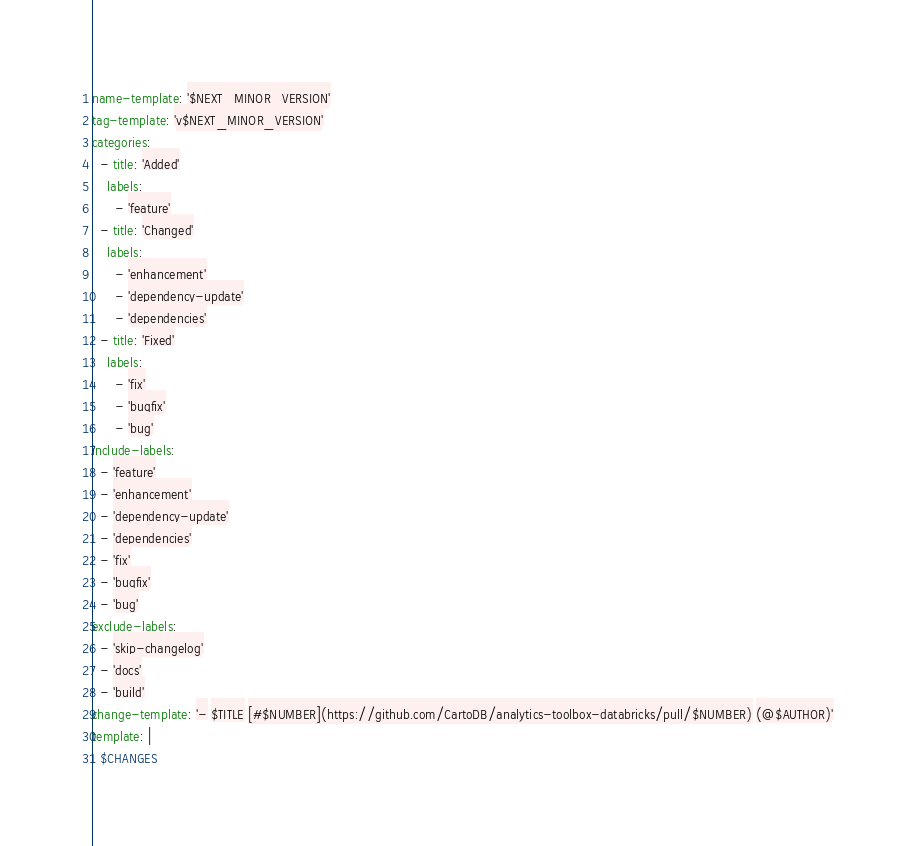Convert code to text. <code><loc_0><loc_0><loc_500><loc_500><_YAML_>name-template: '$NEXT_MINOR_VERSION'
tag-template: 'v$NEXT_MINOR_VERSION'
categories:
  - title: 'Added'
    labels:
      - 'feature'
  - title: 'Changed'
    labels:
      - 'enhancement'
      - 'dependency-update'
      - 'dependencies'
  - title: 'Fixed'
    labels:
      - 'fix'
      - 'bugfix'
      - 'bug'
include-labels:
  - 'feature'
  - 'enhancement'
  - 'dependency-update'
  - 'dependencies'
  - 'fix'
  - 'bugfix'
  - 'bug'
exclude-labels:
  - 'skip-changelog'
  - 'docs'
  - 'build'
change-template: '- $TITLE [#$NUMBER](https://github.com/CartoDB/analytics-toolbox-databricks/pull/$NUMBER) (@$AUTHOR)'
template: |
  $CHANGES
</code> 